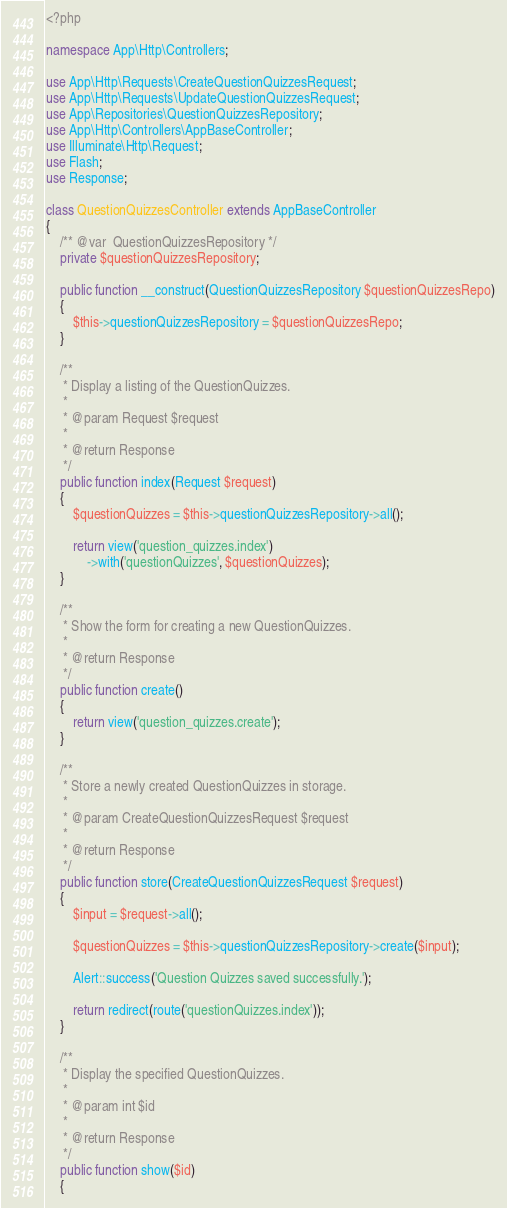<code> <loc_0><loc_0><loc_500><loc_500><_PHP_><?php

namespace App\Http\Controllers;

use App\Http\Requests\CreateQuestionQuizzesRequest;
use App\Http\Requests\UpdateQuestionQuizzesRequest;
use App\Repositories\QuestionQuizzesRepository;
use App\Http\Controllers\AppBaseController;
use Illuminate\Http\Request;
use Flash;
use Response;

class QuestionQuizzesController extends AppBaseController
{
    /** @var  QuestionQuizzesRepository */
    private $questionQuizzesRepository;

    public function __construct(QuestionQuizzesRepository $questionQuizzesRepo)
    {
        $this->questionQuizzesRepository = $questionQuizzesRepo;
    }

    /**
     * Display a listing of the QuestionQuizzes.
     *
     * @param Request $request
     *
     * @return Response
     */
    public function index(Request $request)
    {
        $questionQuizzes = $this->questionQuizzesRepository->all();

        return view('question_quizzes.index')
            ->with('questionQuizzes', $questionQuizzes);
    }

    /**
     * Show the form for creating a new QuestionQuizzes.
     *
     * @return Response
     */
    public function create()
    {
        return view('question_quizzes.create');
    }

    /**
     * Store a newly created QuestionQuizzes in storage.
     *
     * @param CreateQuestionQuizzesRequest $request
     *
     * @return Response
     */
    public function store(CreateQuestionQuizzesRequest $request)
    {
        $input = $request->all();

        $questionQuizzes = $this->questionQuizzesRepository->create($input);

        Alert::success('Question Quizzes saved successfully.');

        return redirect(route('questionQuizzes.index'));
    }

    /**
     * Display the specified QuestionQuizzes.
     *
     * @param int $id
     *
     * @return Response
     */
    public function show($id)
    {</code> 